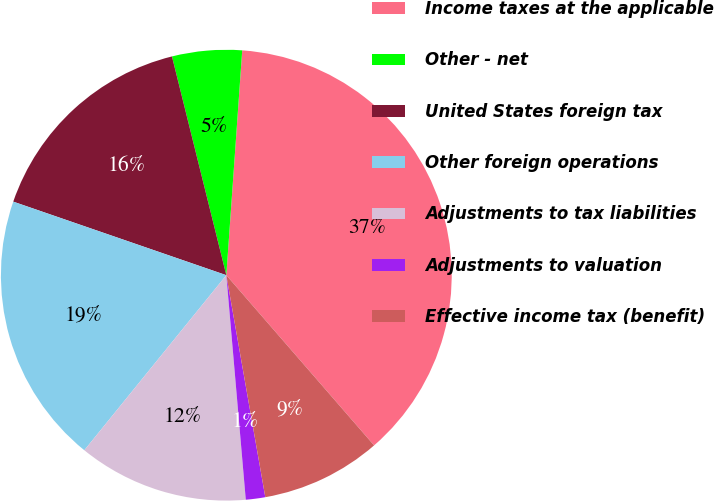Convert chart to OTSL. <chart><loc_0><loc_0><loc_500><loc_500><pie_chart><fcel>Income taxes at the applicable<fcel>Other - net<fcel>United States foreign tax<fcel>Other foreign operations<fcel>Adjustments to tax liabilities<fcel>Adjustments to valuation<fcel>Effective income tax (benefit)<nl><fcel>37.49%<fcel>5.0%<fcel>15.83%<fcel>19.44%<fcel>12.22%<fcel>1.39%<fcel>8.61%<nl></chart> 